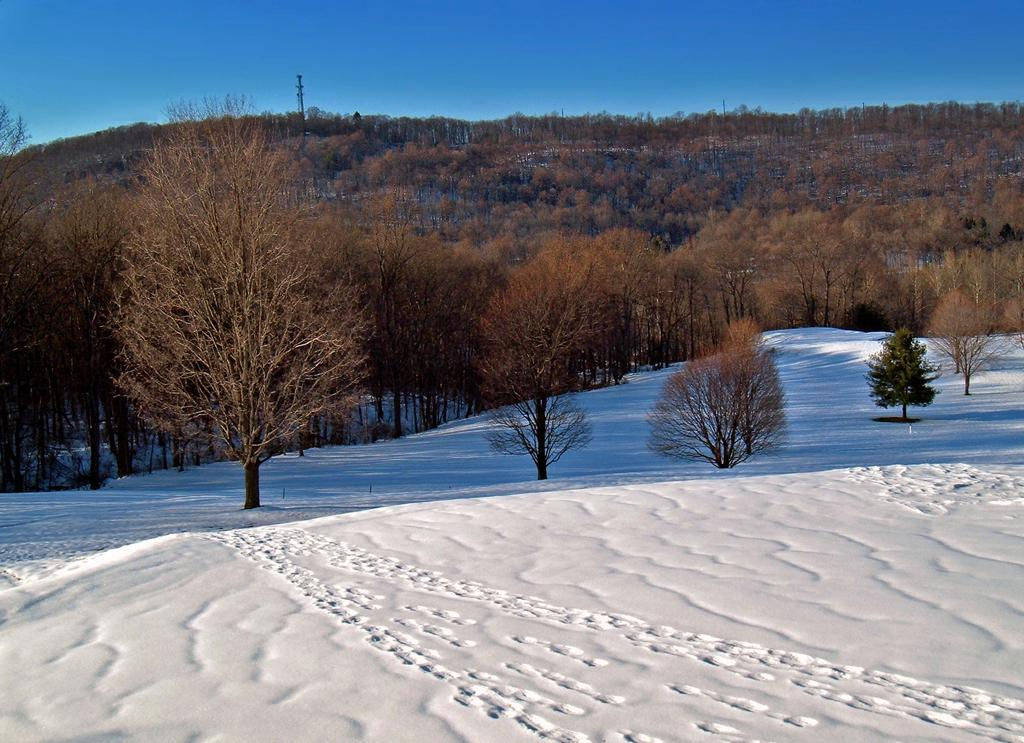What type of vegetation can be seen in the image? There are many trees and plants in the image. What is the weather like in the image? The presence of snow suggests that it is cold or wintry in the image. What can be seen in the background of the image? There is a hill, trees, a tower, and the sky visible in the background of the image. What type of music can be heard playing in the image? There is no indication of music or any sound in the image, as it is a still photograph. 